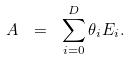Convert formula to latex. <formula><loc_0><loc_0><loc_500><loc_500>A \ = \ \sum _ { i = 0 } ^ { D } \theta _ { i } E _ { i } .</formula> 